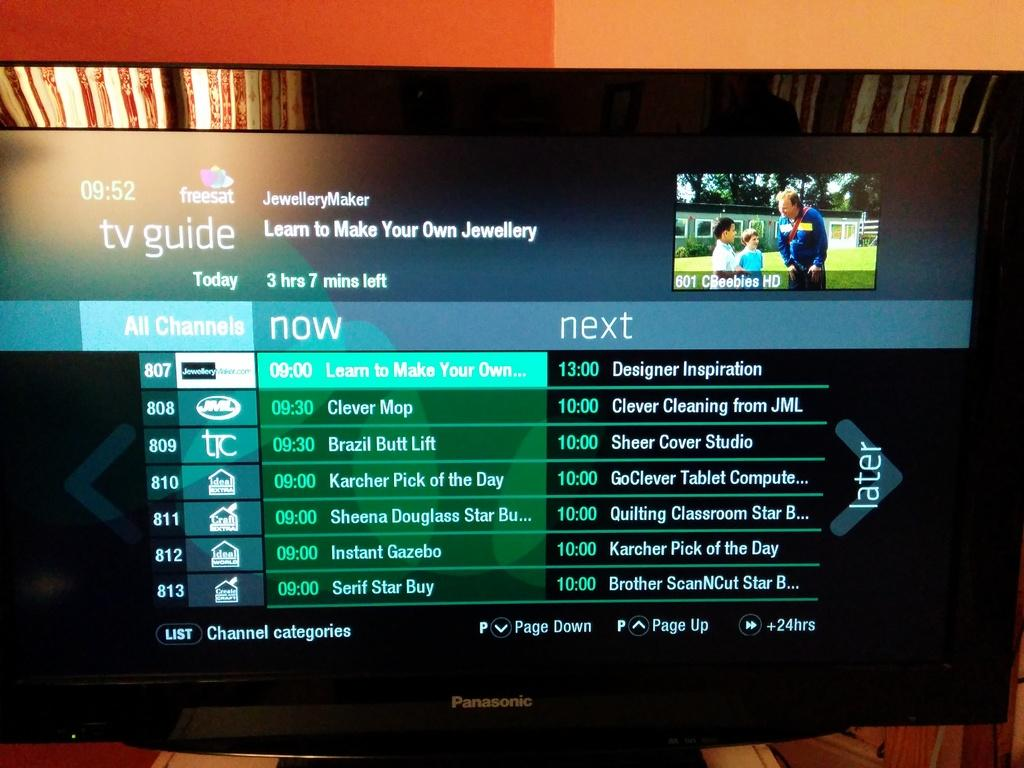<image>
Present a compact description of the photo's key features. A tv with the Tv Guide displayed with a list of shows. 